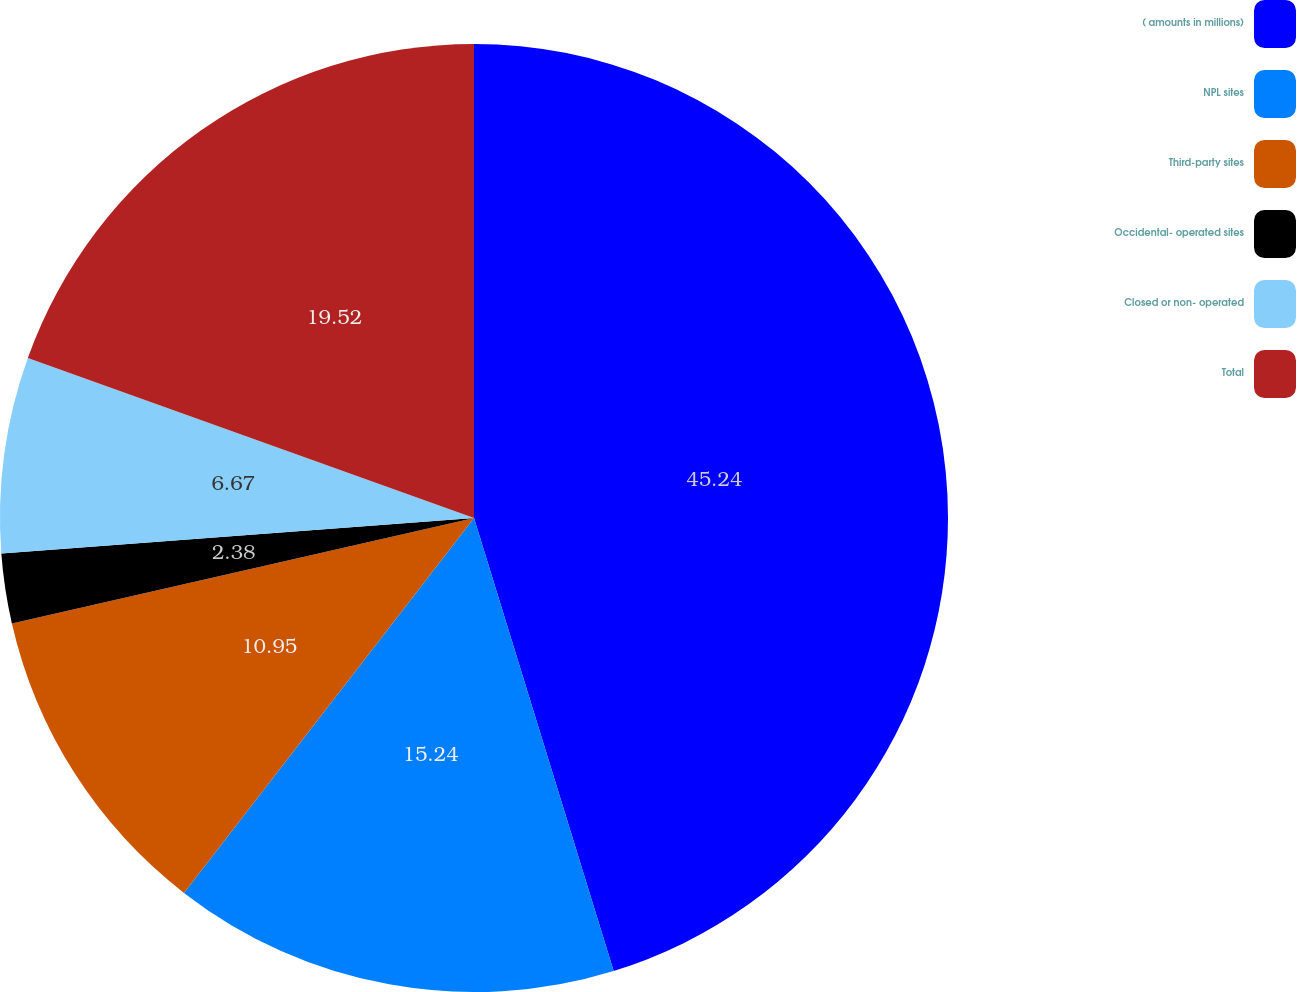Convert chart to OTSL. <chart><loc_0><loc_0><loc_500><loc_500><pie_chart><fcel>( amounts in millions)<fcel>NPL sites<fcel>Third-party sites<fcel>Occidental- operated sites<fcel>Closed or non- operated<fcel>Total<nl><fcel>45.24%<fcel>15.24%<fcel>10.95%<fcel>2.38%<fcel>6.67%<fcel>19.52%<nl></chart> 